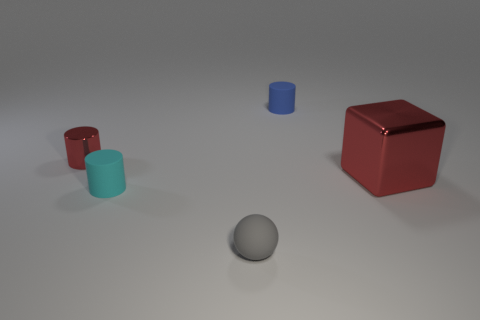Is there any other thing that has the same shape as the big thing?
Provide a succinct answer. No. What size is the thing that is the same color as the cube?
Give a very brief answer. Small. How many other objects are the same shape as the large object?
Offer a very short reply. 0. What number of other things are there of the same size as the red shiny block?
Your response must be concise. 0. Is the color of the small metallic cylinder the same as the large shiny object?
Offer a very short reply. Yes. Is the shape of the red object right of the small blue object the same as  the small cyan matte thing?
Make the answer very short. No. How many matte objects are both on the right side of the cyan matte cylinder and behind the tiny gray ball?
Your response must be concise. 1. What is the material of the small red thing?
Offer a terse response. Metal. Is there any other thing that has the same color as the small shiny cylinder?
Your answer should be compact. Yes. Is the small gray sphere made of the same material as the big red cube?
Provide a succinct answer. No. 